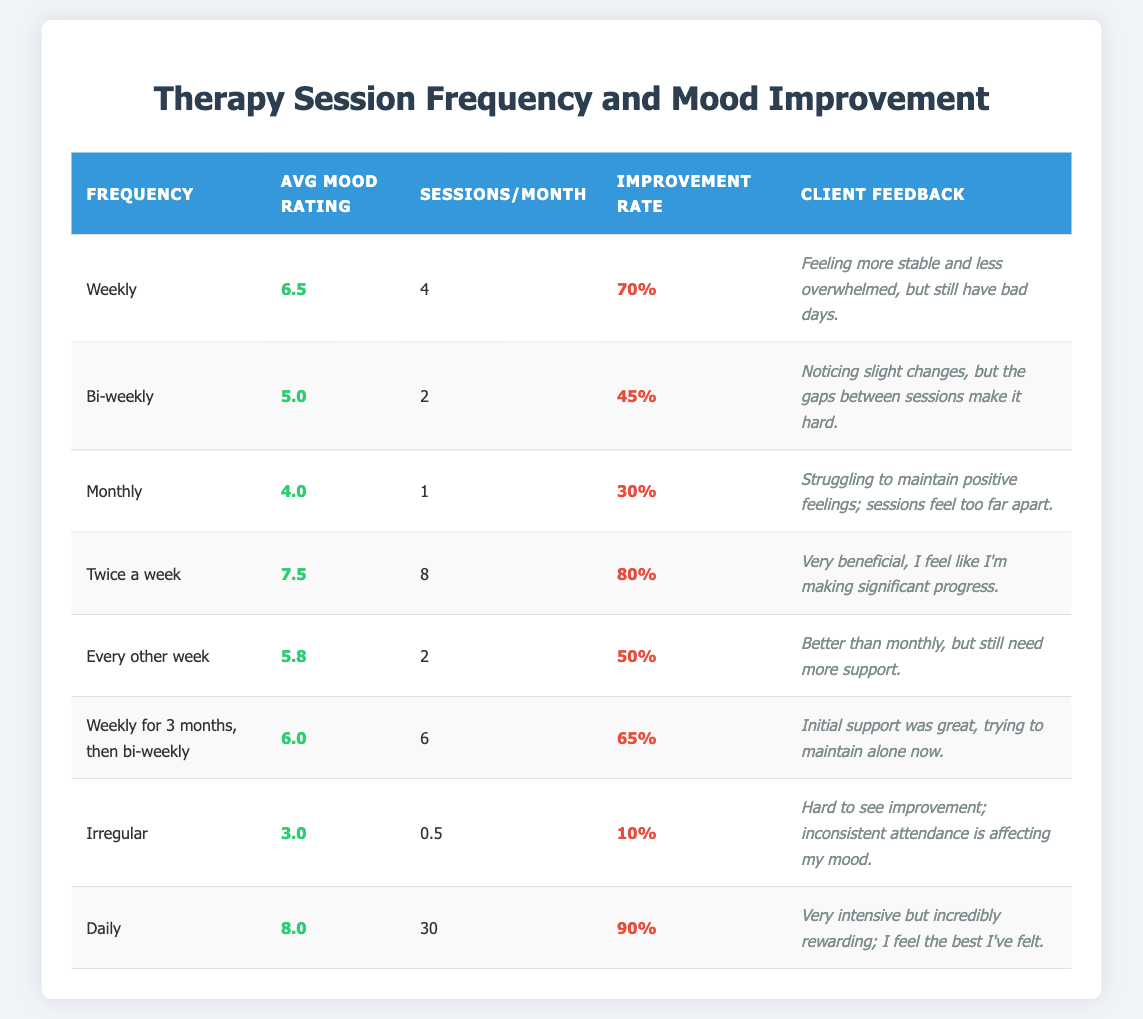What is the average mood rating for clients who attend therapy sessions twice a week? The table shows that clients who attend therapy twice a week have an average mood rating of 7.5.
Answer: 7.5 How many sessions per month do clients attending therapy bi-weekly receive? According to the table, clients who have bi-weekly therapy sessions attend 2 sessions per month.
Answer: 2 What is the improvement rate for clients who have irregular therapy sessions? The table indicates that the improvement rate for clients with irregular therapy sessions is 10%.
Answer: 10% Which frequency of therapy sessions has the highest improvement rate? The highest improvement rate is observed for daily therapy sessions, with a rate of 90%.
Answer: 90% What is the average mood rating for clients attending sessions once a month compared to those attending bi-weekly? Monthly sessions have an average mood rating of 4.0, while bi-weekly sessions have an average mood rating of 5.0.
Answer: 4.0 (monthly) vs 5.0 (bi-weekly) Is the improvement rate higher for clients attending therapy daily or those attending therapy twice a week? According to the table, the improvement rate for clients attending daily sessions is 90%, while for those attending twice a week, it is 80%. Daily sessions have a higher improvement rate.
Answer: Yes What is the total average mood rating for clients attending therapy weekly and those attending every other week? Adding the average mood ratings of weekly (6.5) and every other week (5.8) sessions gives a total of 12.3. To find the average, divide by 2: 12.3 / 2 = 6.15.
Answer: 6.15 Which frequency shows the largest difference in average mood rating between its average and that of clients with irregular sessions? Irregular sessions have an average mood rating of 3.0. The largest difference is observed with daily sessions, which have an average of 8.0, resulting in a difference of 5.0 (8.0 - 3.0).
Answer: Daily sessions Are clients who attend therapy monthly reporting higher mood ratings than those attending bi-weekly sessions? The average mood rating for monthly clients is 4.0, while for bi-weekly clients, it is 5.0. Hence, clients attending bi-weekly sessions report higher mood ratings.
Answer: No 